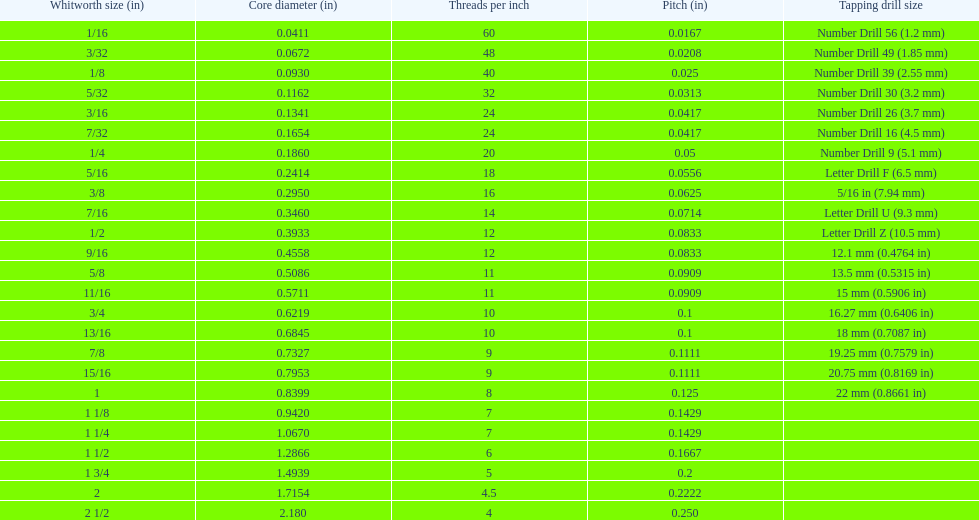What is the next whitworth size (in) below 1/8? 5/32. 